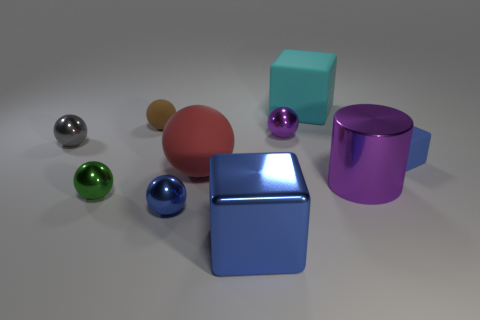Subtract all blue rubber cubes. How many cubes are left? 2 Subtract all cyan cubes. How many cubes are left? 2 Subtract all balls. How many objects are left? 4 Subtract all small green cylinders. Subtract all brown matte things. How many objects are left? 9 Add 1 big blue objects. How many big blue objects are left? 2 Add 4 small purple metal spheres. How many small purple metal spheres exist? 5 Subtract 0 green cylinders. How many objects are left? 10 Subtract 1 cylinders. How many cylinders are left? 0 Subtract all yellow balls. Subtract all red cylinders. How many balls are left? 6 Subtract all brown cylinders. How many cyan cubes are left? 1 